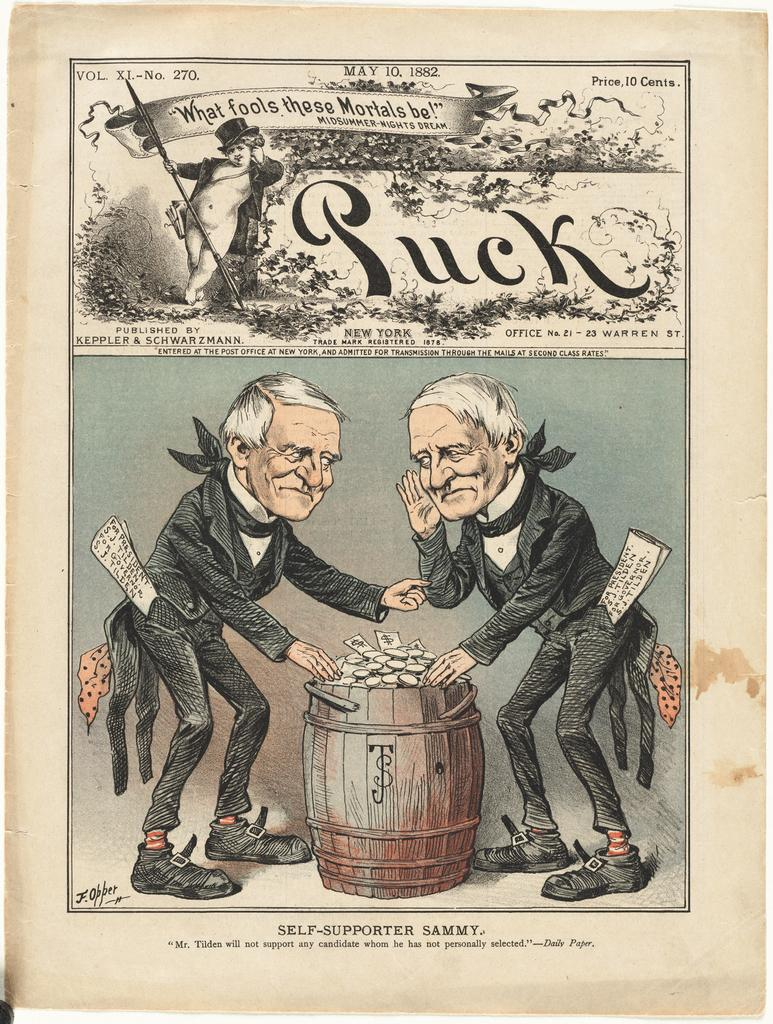<image>
Render a clear and concise summary of the photo. an old page that says 'what fools these mortals be!' on it 